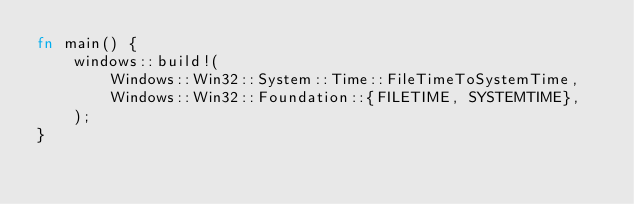Convert code to text. <code><loc_0><loc_0><loc_500><loc_500><_Rust_>fn main() {
    windows::build!(
        Windows::Win32::System::Time::FileTimeToSystemTime,
        Windows::Win32::Foundation::{FILETIME, SYSTEMTIME},
    );
}</code> 